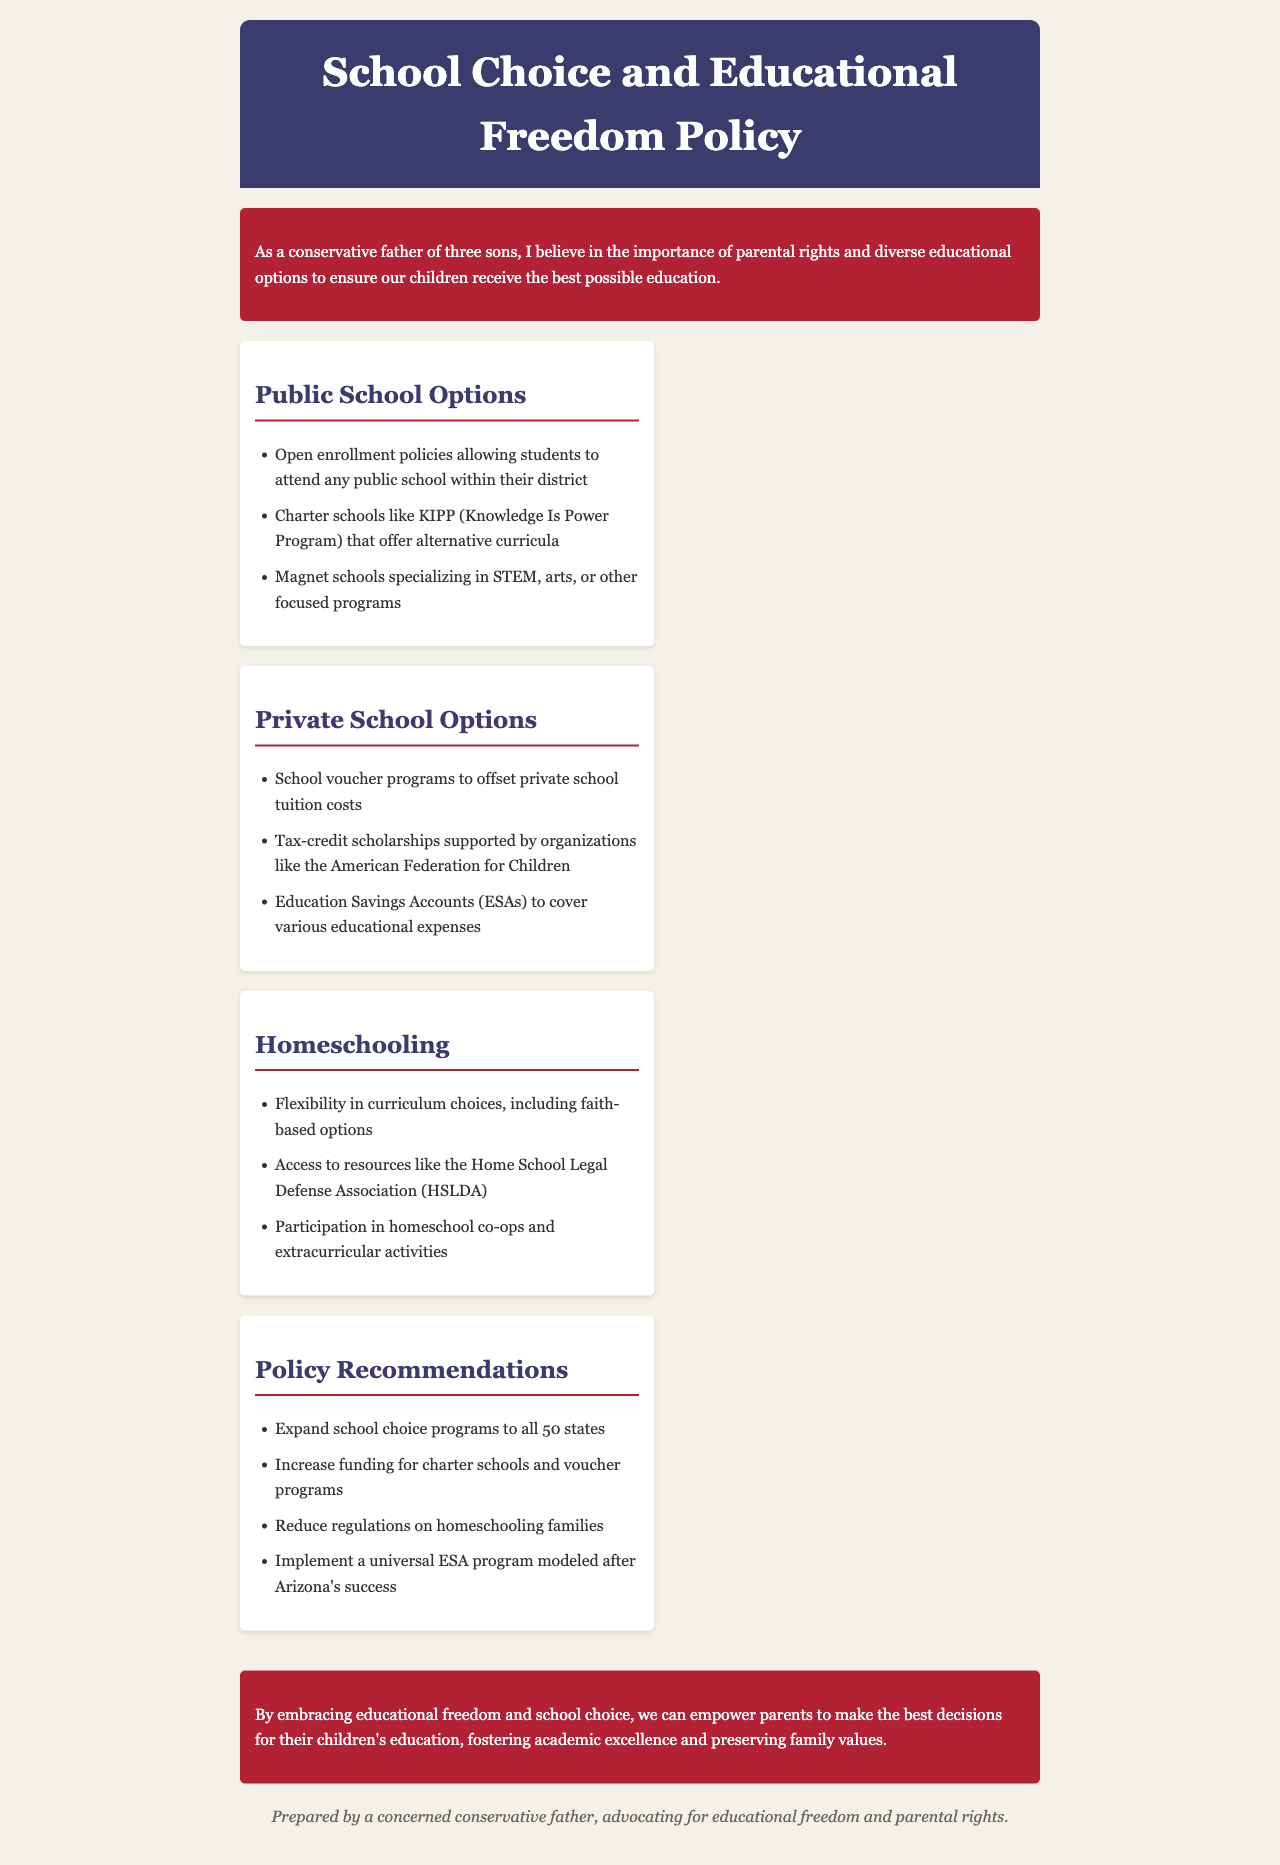What is the title of the document? The title of the document is mentioned in the header section.
Answer: School Choice and Educational Freedom Policy What are the public school options listed? The document lists specific public school options in the "Public School Options" section.
Answer: Open enrollment, charter schools, magnet schools What type of organizations support tax-credit scholarships? The document specifies an organization that supports tax-credit scholarships.
Answer: American Federation for Children What is one of the key homeschooling resources mentioned? The document highlights a specific resource for homeschooling families.
Answer: Home School Legal Defense Association What is the recommended action regarding charter schools? The policy recommendations include specific actions regarding charter schools.
Answer: Increase funding for charter schools What is the main focus of the policy document? The introductory statement outlines the primary focus of the document.
Answer: Educational freedom and parental rights How many sons does the author have? The document begins with information about the author's family.
Answer: Three sons Which state is mentioned as a model for a universal ESA program? The document cites a specific state as a successful model for the ESA program.
Answer: Arizona What is the purpose of school voucher programs? The document explains a specific purpose for school voucher programs.
Answer: Offset private school tuition costs 